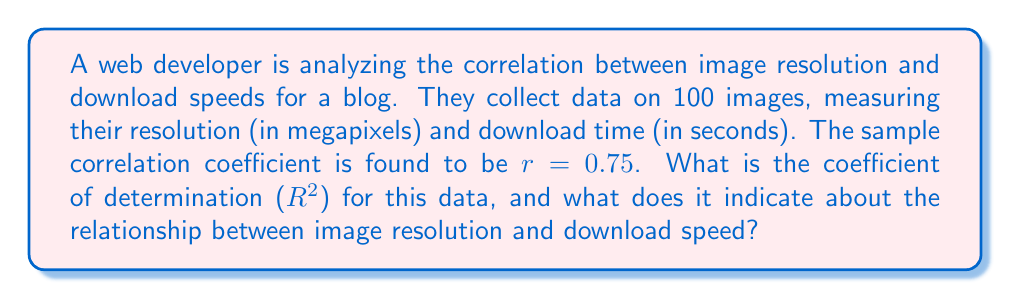Show me your answer to this math problem. To solve this problem, we need to understand the relationship between the correlation coefficient ($r$) and the coefficient of determination ($R^2$).

1. The correlation coefficient ($r$) measures the strength and direction of a linear relationship between two variables. It ranges from -1 to 1.

2. The coefficient of determination ($R^2$) is the square of the correlation coefficient. It represents the proportion of the variance in the dependent variable that is predictable from the independent variable.

3. To calculate $R^2$, we simply square the given correlation coefficient:

   $$R^2 = r^2 = (0.75)^2 = 0.5625$$

4. Interpretation of $R^2$:
   - $R^2$ ranges from 0 to 1
   - It can be expressed as a percentage by multiplying by 100
   - In this case, $R^2 = 0.5625$ or 56.25%

5. This result indicates that approximately 56.25% of the variability in download speeds can be explained by the linear relationship with image resolution.

6. The remaining 43.75% of the variability is due to other factors or random variation not accounted for by this linear model.

This information is valuable for a web developer optimizing visual content, as it suggests a moderate to strong relationship between image resolution and download speed, but also indicates that other factors play a significant role in determining download times.
Answer: $R^2 = 0.5625$ or 56.25%, indicating that 56.25% of the variability in download speeds can be explained by the linear relationship with image resolution. 